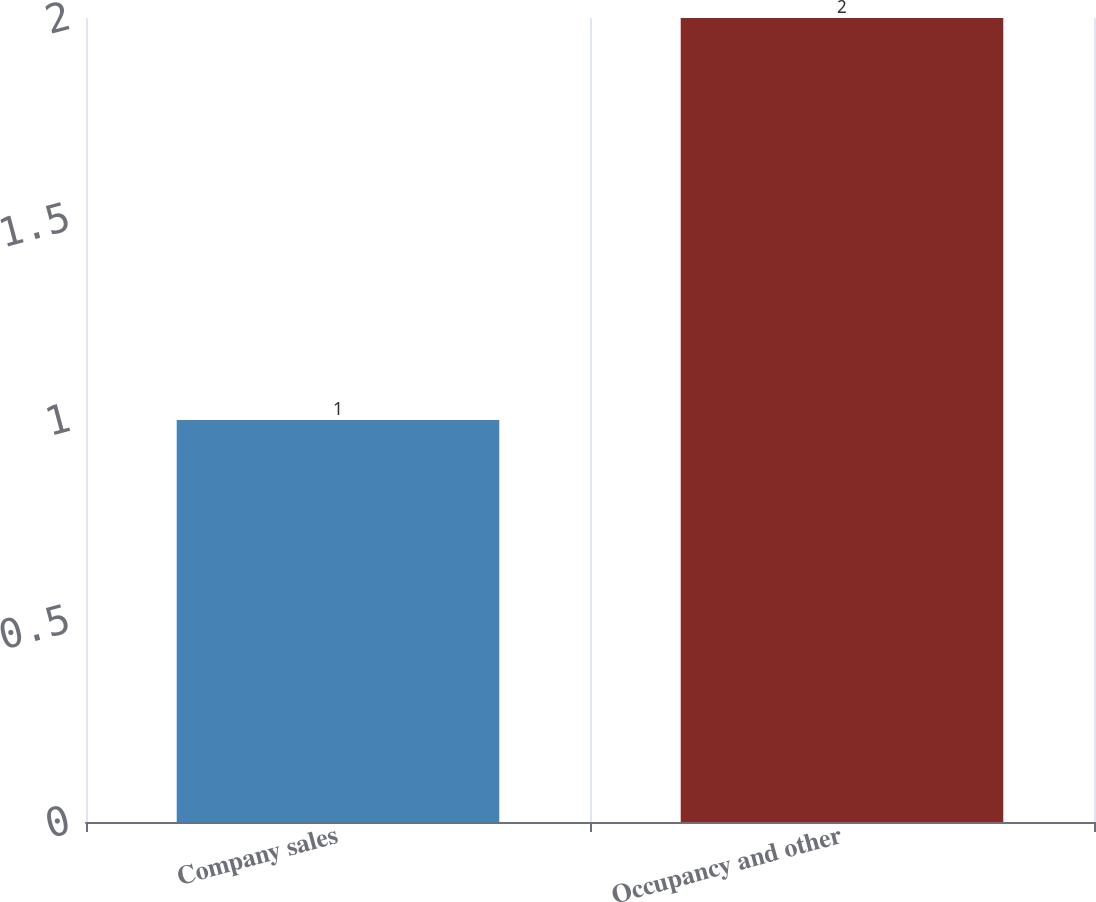Convert chart. <chart><loc_0><loc_0><loc_500><loc_500><bar_chart><fcel>Company sales<fcel>Occupancy and other<nl><fcel>1<fcel>2<nl></chart> 